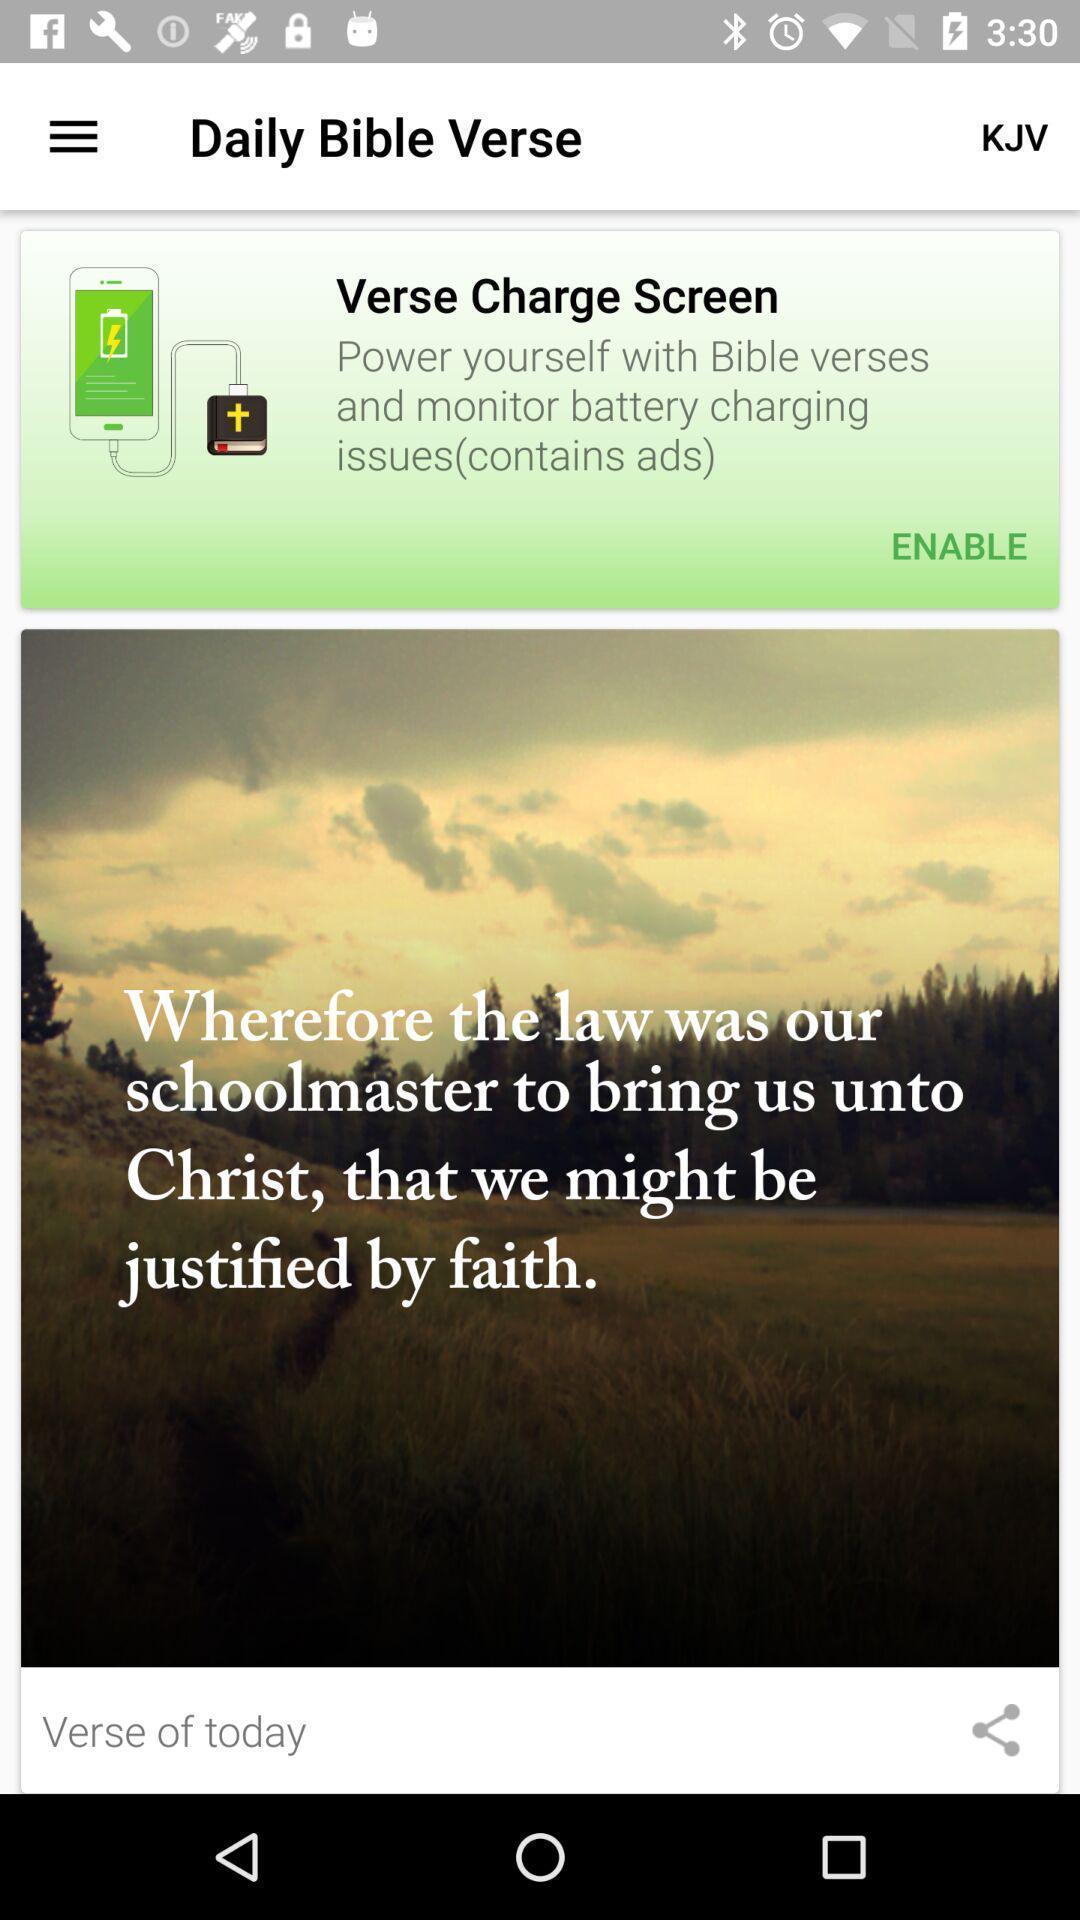Tell me about the visual elements in this screen capture. Verse charge screen in daily bible verse. 